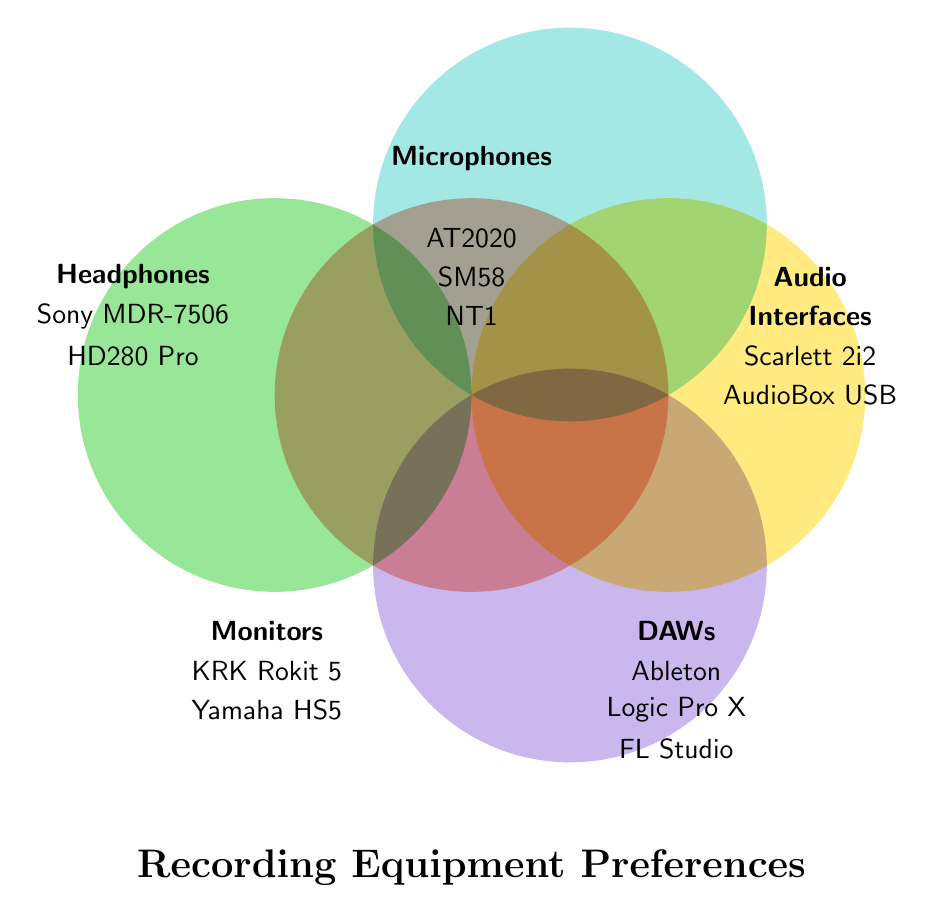How many different categories are represented in the Venn Diagram? Identify unique categories in the figure (Microphones, Audio Interfaces, DAWs, Monitors, Headphones)
Answer: 5 Which category includes the Shure SM58? Locate the Shure SM58 under the category section
Answer: Microphones What items are listed under the Audio Interfaces category? Identify the items listed under Audio Interfaces (Focusrite Scarlett 2i2 and PreSonus AudioBox USB 96)
Answer: Scarlett 2i2, AudioBox USB 96 Which DAW options are available according to the figure? Locate and list the DAW options (Ableton Live, Logic Pro X, FL Studio)
Answer: Ableton Live, Logic Pro X, FL Studio How many categories have exactly two items listed? Count categories with two items: Audio Interfaces (2), Monitors (2), Headphones (2)
Answer: 3 What category is located at the top of the diagram? Observe the top position in the diagram and identify the category
Answer: Microphones Which category do KRK Rokit 5 and Yamaha HS5 belong to? Locate KRK Rokit 5 and Yamaha HS5 and identify their category
Answer: Monitors List all the headphones mentioned in the figure. Identify the items under Headphones (Sony MDR-7506, Sennheiser HD280 Pro)
Answer: Sony MDR-7506, Sennheiser HD280 Pro Which category is positioned on the left side of the diagram? Observe the placement of categories and locate the leftmost category
Answer: Headphones What is the title of the Venn Diagram? Read the main title of the diagram located at the bottom center
Answer: Recording Equipment Preferences 